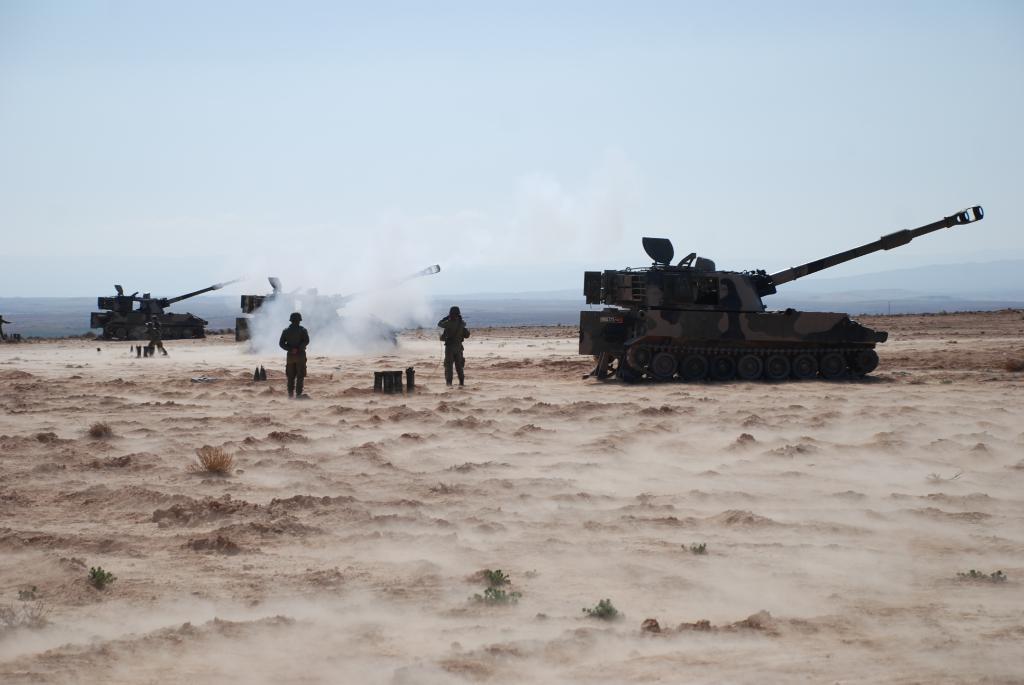How would you summarize this image in a sentence or two? In this image there is the sky truncated towards the top of the image, there are military tanks, there are persons standing, there are objects on the ground, there are plants, there is sand truncated towards the bottom of the image, there is sand truncated towards the right of the image, there is sand truncated towards the left of the image, there is an object truncated towards the left of the image. 